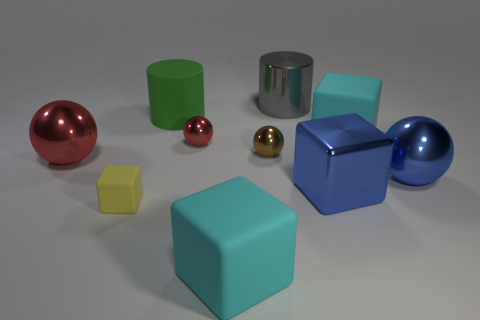Are there any blue objects that have the same material as the green thing?
Your answer should be very brief. No. How many big cyan shiny balls are there?
Your answer should be very brief. 0. What is the material of the blue object in front of the large blue sphere right of the big metallic cylinder?
Your answer should be compact. Metal. There is a small object that is the same material as the small brown sphere; what is its color?
Give a very brief answer. Red. There is a cyan object that is behind the small yellow rubber cube; is its size the same as the cyan matte cube that is in front of the large red metal thing?
Ensure brevity in your answer.  Yes. What number of spheres are either big things or tiny blue matte objects?
Give a very brief answer. 2. Do the big cylinder behind the big rubber cylinder and the big red ball have the same material?
Keep it short and to the point. Yes. What number of other objects are there of the same size as the gray shiny thing?
Your response must be concise. 6. What number of large things are either yellow rubber cubes or cyan matte cubes?
Your response must be concise. 2. Is the color of the rubber cylinder the same as the large metal cylinder?
Keep it short and to the point. No. 